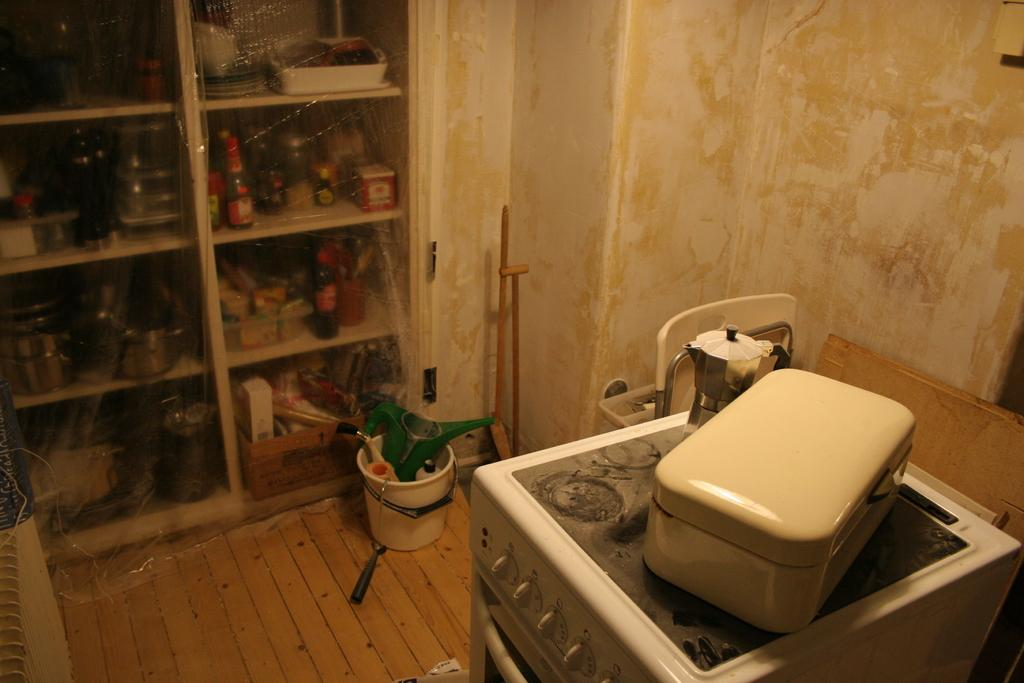What type of storage unit is visible in the image? There is a wooden cupboard in the image. What items can be found inside the wooden cupboard? There are vessels and bottles in the wooden cupboard. How is the wooden cupboard protected or covered? A cover is present on the wooden cupboard. What other objects are present in the image besides the wooden cupboard? There is a bucket, an oven, and a box on the oven in the image. What type of surface is visible in the background? There are wooden planks visible in the background. What type of grass is growing on the oven in the image? There is no grass present in the image; the oven is a kitchen appliance and not a garden or outdoor area. 